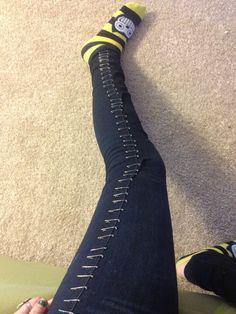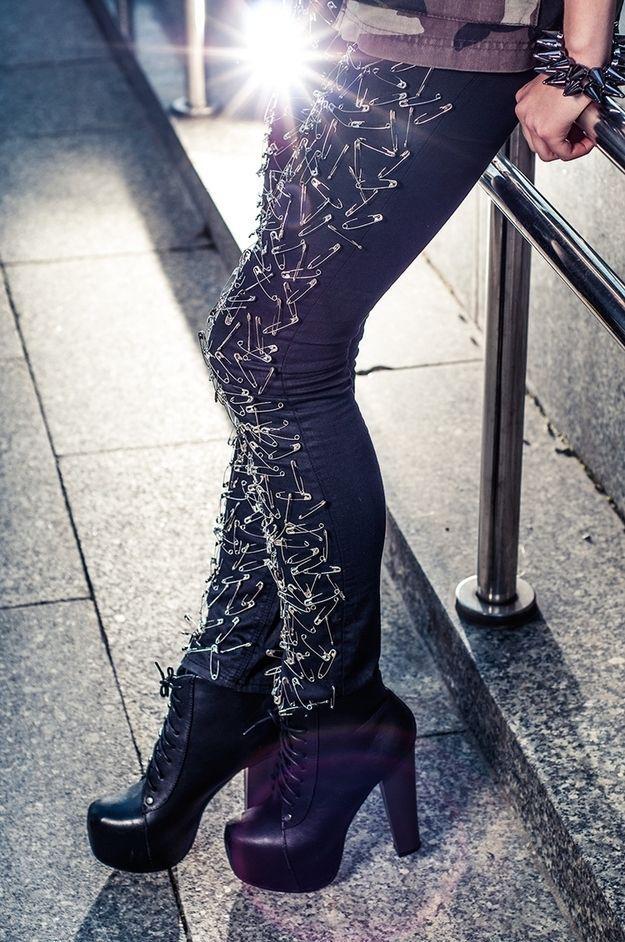The first image is the image on the left, the second image is the image on the right. Analyze the images presented: Is the assertion "someone is wearing a pair of pants full of safety pins and a pair of heels" valid? Answer yes or no. Yes. The first image is the image on the left, the second image is the image on the right. For the images shown, is this caption "One of the images shows high heeled platform shoes." true? Answer yes or no. Yes. 